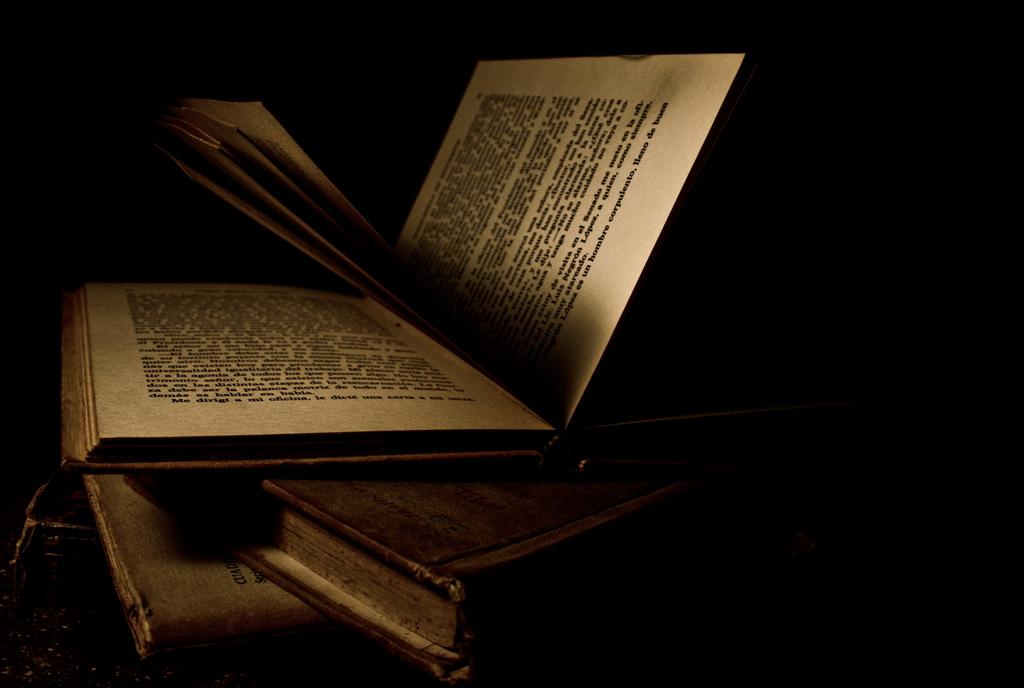<image>
Give a short and clear explanation of the subsequent image. An opened book written in Spanish with the words "un hombre" among others being displayed. 